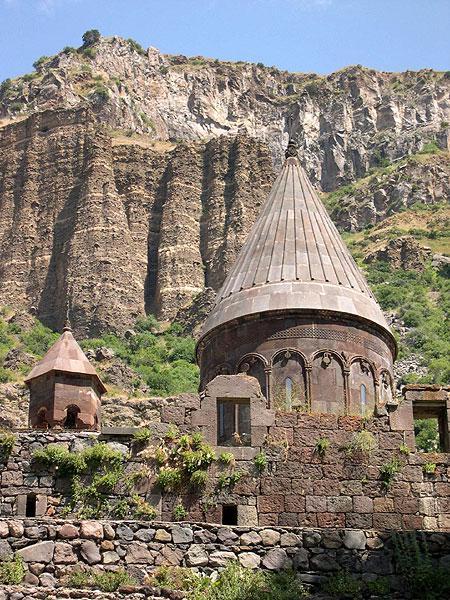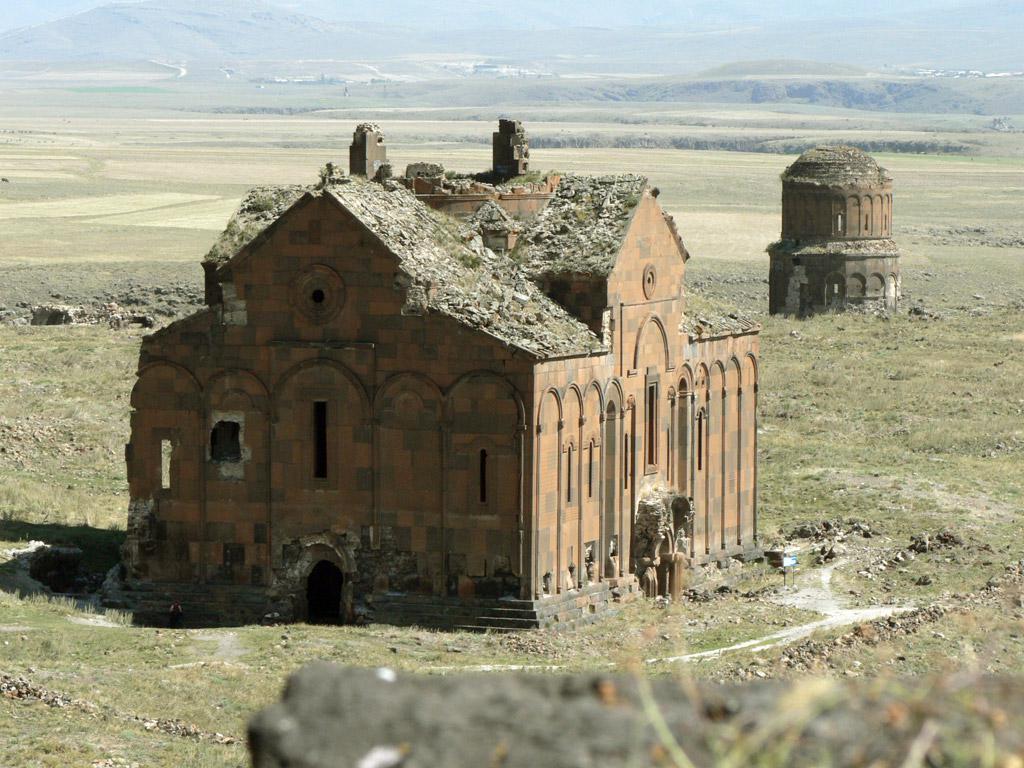The first image is the image on the left, the second image is the image on the right. Analyze the images presented: Is the assertion "There is a cross atop the building in one of the images." valid? Answer yes or no. No. 